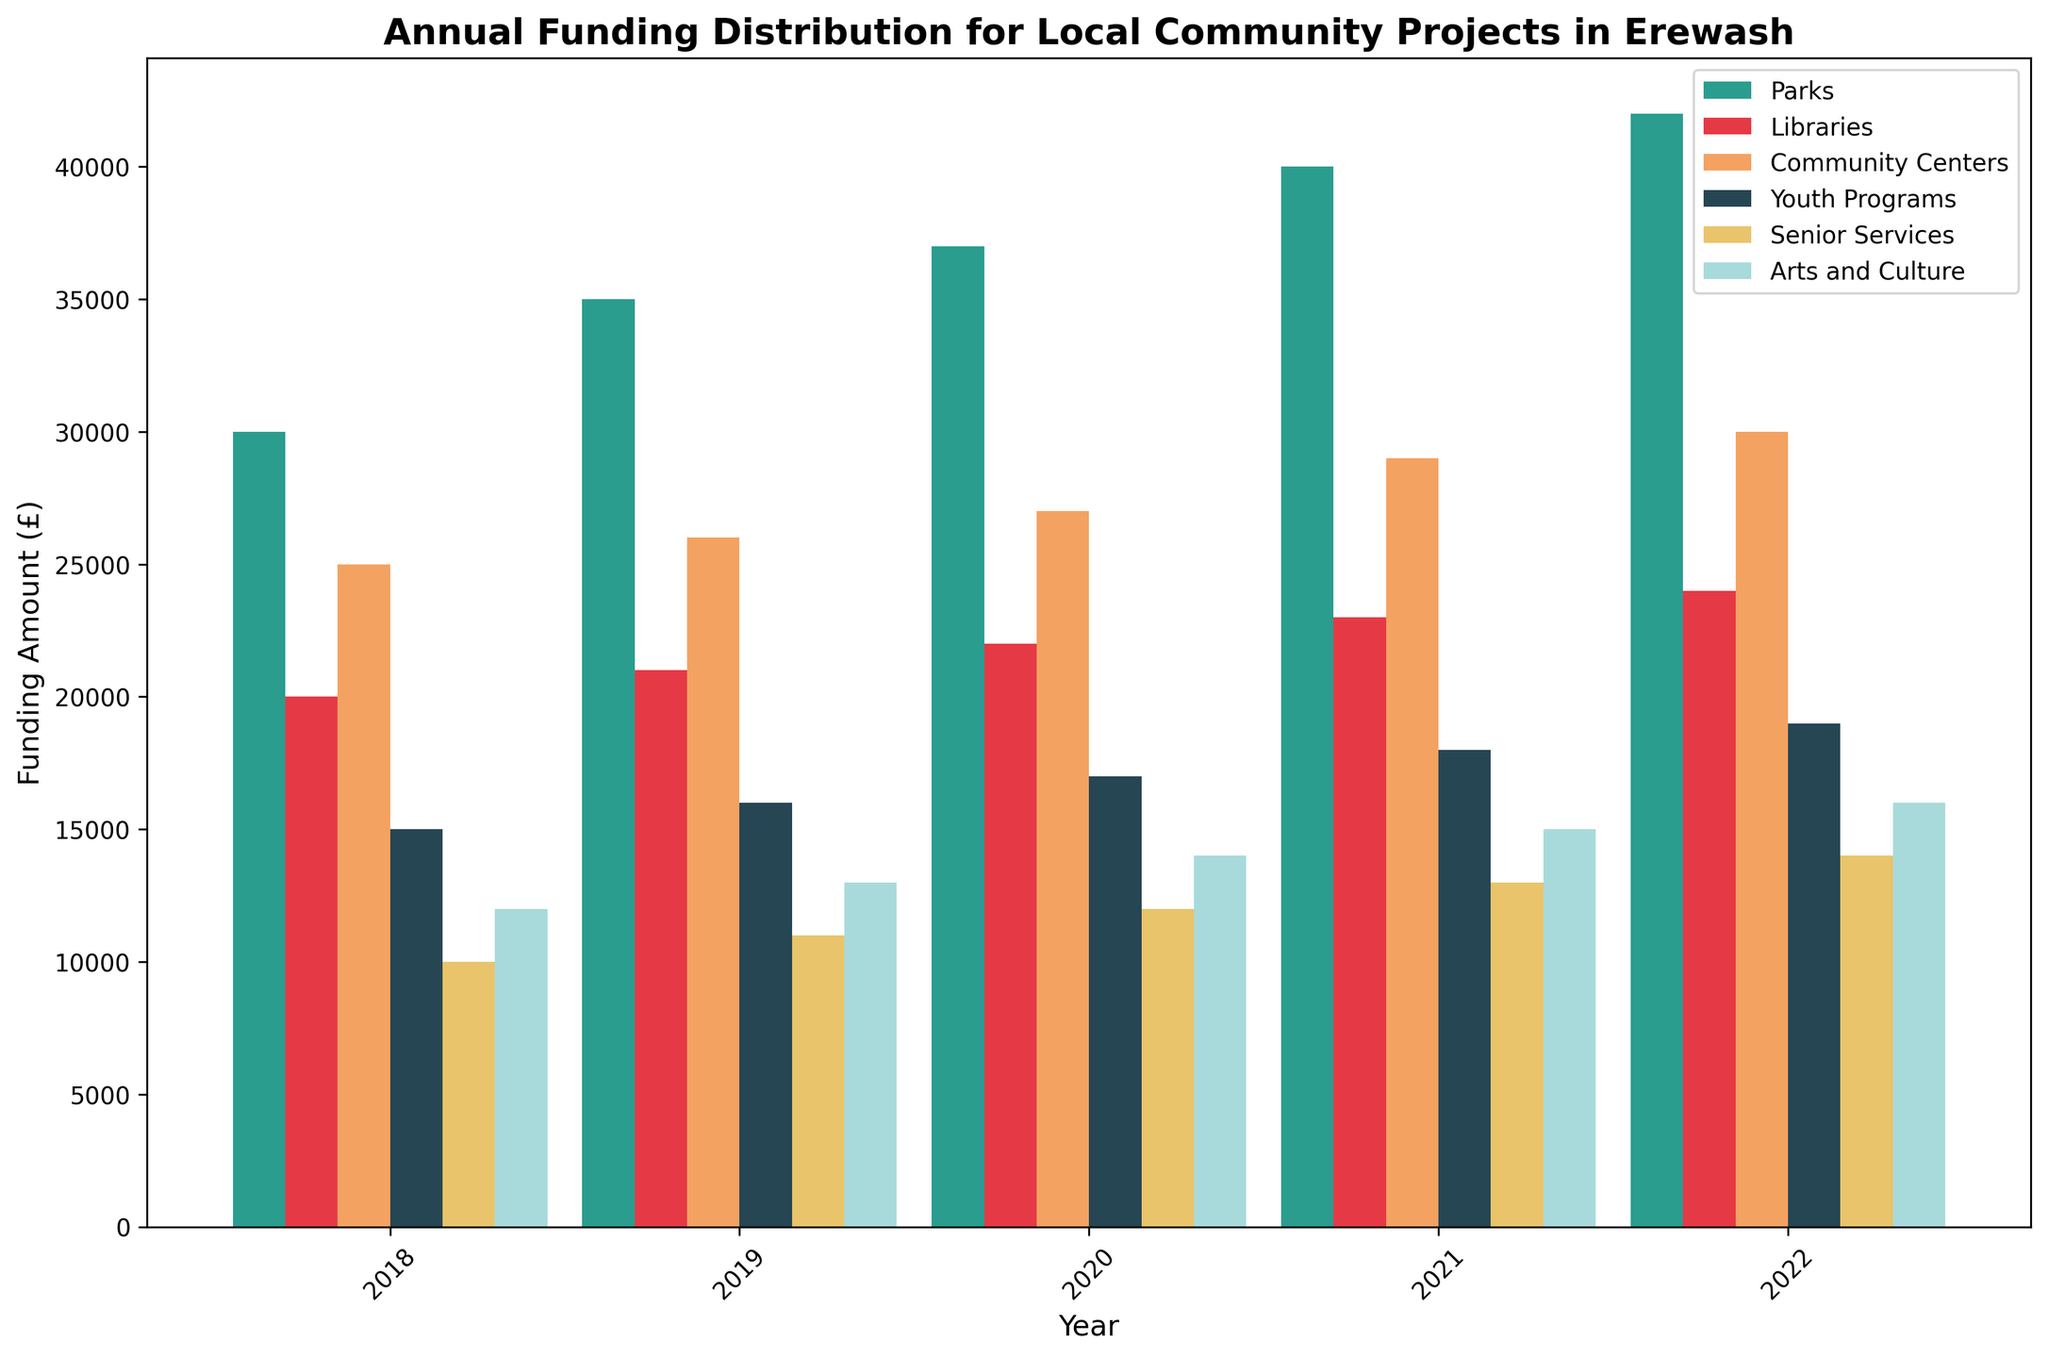What's the total funding for Parks in 2018 and 2022? Sum the amounts for Parks in 2018 (£30,000) and 2022 (£42,000). 30,000 + 42,000 = 72,000
Answer: £72,000 Which category received the highest funding in 2021? Compare the height of bars for all categories in 2021. Parks' funding (£40,000) is the highest among all categories.
Answer: Parks Did funding for Arts and Culture increase or decrease from 2018 to 2020? Compare the heights of the bars for Arts and Culture in 2018 (£12,000) and 2020 (£14,000). Funding increased.
Answer: Increased What's the average annual funding for Libraries from 2018 to 2022? Sum the funding for Libraries over the years (20,000 + 21,000 + 22,000 + 23,000 + 24,000 = 110,000) and divide by number of years (110,000 / 5 = 22,000).
Answer: £22,000 Which category received the least funding in 2019? Compare the heights of the bars for all categories in 2019. Senior Services received the least funding (£11,000).
Answer: Senior Services Is the funding for Youth Programs in 2020 higher than in 2019? Compare the heights of the bars for Youth Programs in 2019 (£16,000) and 2020 (£17,000). Funding is higher in 2020.
Answer: Yes How much more funding did Community Centers receive in 2022 compared to 2018? Subtract the amount for Community Centers in 2018 (£25,000) from the amount in 2022 (£30,000). 30,000 - 25,000 = 5,000
Answer: £5,000 What's the trend for Parks funding from 2018 to 2022? Observe the heights of the bars for Parks from 2018 to 2022 (30,000, 35,000, 37,000, 40,000, 42,000). Each year the funding increased.
Answer: Increasing Which two categories had nearly equal funding in 2021? Compare the heights of the bars for 2021. Youth Programs (£18,000) and Arts and Culture (£15,000) had similar funding.
Answer: Youth Programs and Arts and Culture 